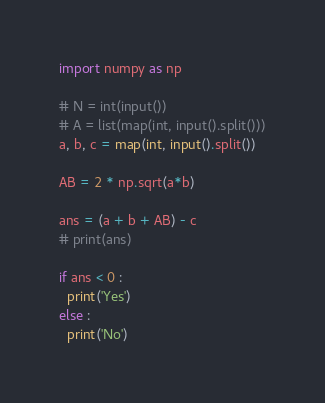Convert code to text. <code><loc_0><loc_0><loc_500><loc_500><_Python_>import numpy as np

# N = int(input())
# A = list(map(int, input().split()))
a, b, c = map(int, input().split())

AB = 2 * np.sqrt(a*b)

ans = (a + b + AB) - c
# print(ans)

if ans < 0 :
  print('Yes')
else :
  print('No')</code> 